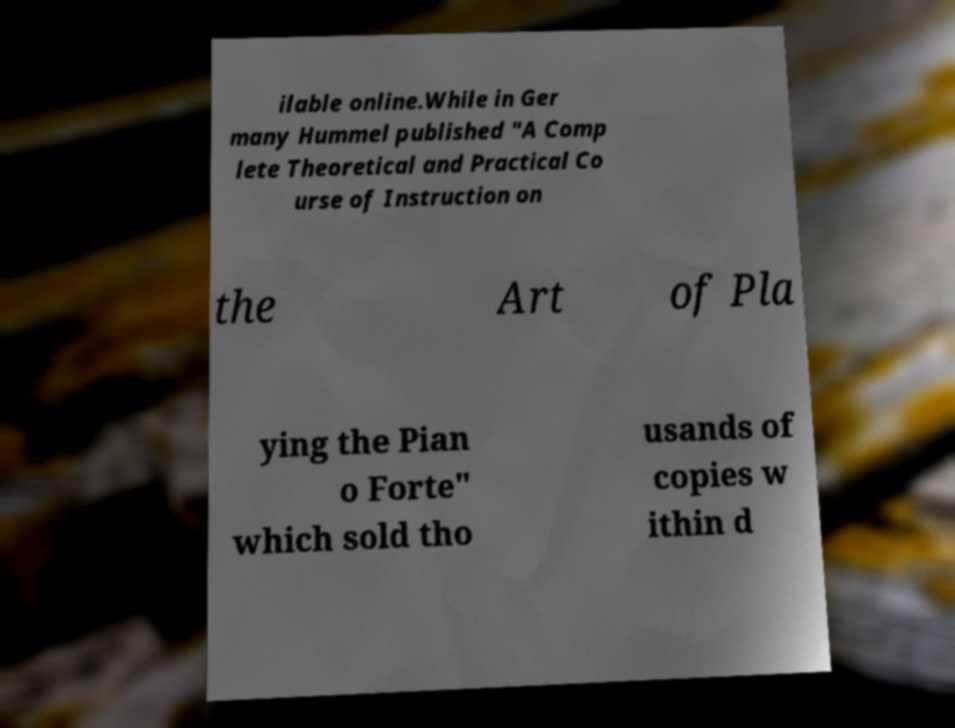Could you extract and type out the text from this image? ilable online.While in Ger many Hummel published "A Comp lete Theoretical and Practical Co urse of Instruction on the Art of Pla ying the Pian o Forte" which sold tho usands of copies w ithin d 